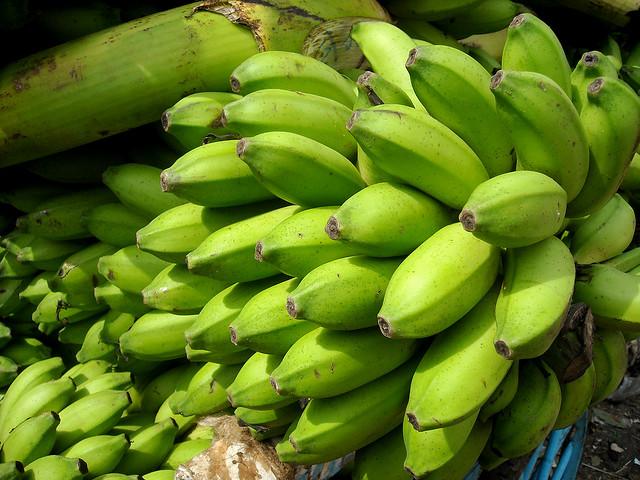Is the banana ripe?
Answer briefly. No. What color is the bananas?
Write a very short answer. Green. What are the bananas sitting on?
Keep it brief. Table. Is the fruit ripe?
Quick response, please. No. Is there cheese in this picture?
Keep it brief. No. Are the bananas delicious?
Keep it brief. Yes. What color is the food in the image?
Be succinct. Green. Are the bananas ripe yet?
Be succinct. No. What color is the fruit?
Keep it brief. Green. Are these bananas ripe?
Concise answer only. No. Are the bananas ripe?
Quick response, please. No. What colors are the bananas?
Concise answer only. Green. Are the bananas green?
Concise answer only. Yes. How many green bananas?
Give a very brief answer. Many. Are all these foods green?
Keep it brief. Yes. Is this fruit ripe?
Short answer required. No. Are these bananas good for baking?
Be succinct. No. Is this plant edible?
Be succinct. Yes. What brand of banana is pictured?
Be succinct. Dole. Are these bananas in a bunch or singles?
Quick response, please. Bunch. Are all the fruits yellow?
Quick response, please. No. Is this a tropical fruit?
Give a very brief answer. Yes. What kind of fruits are shown?
Quick response, please. Bananas. Is fruit ripe?
Short answer required. No. Are the fruits ripe?
Quick response, please. No. What color are the bananas?
Short answer required. Green. Are the bananas ripe enough to eat?
Short answer required. No. Are these dole bananas?
Quick response, please. No. 